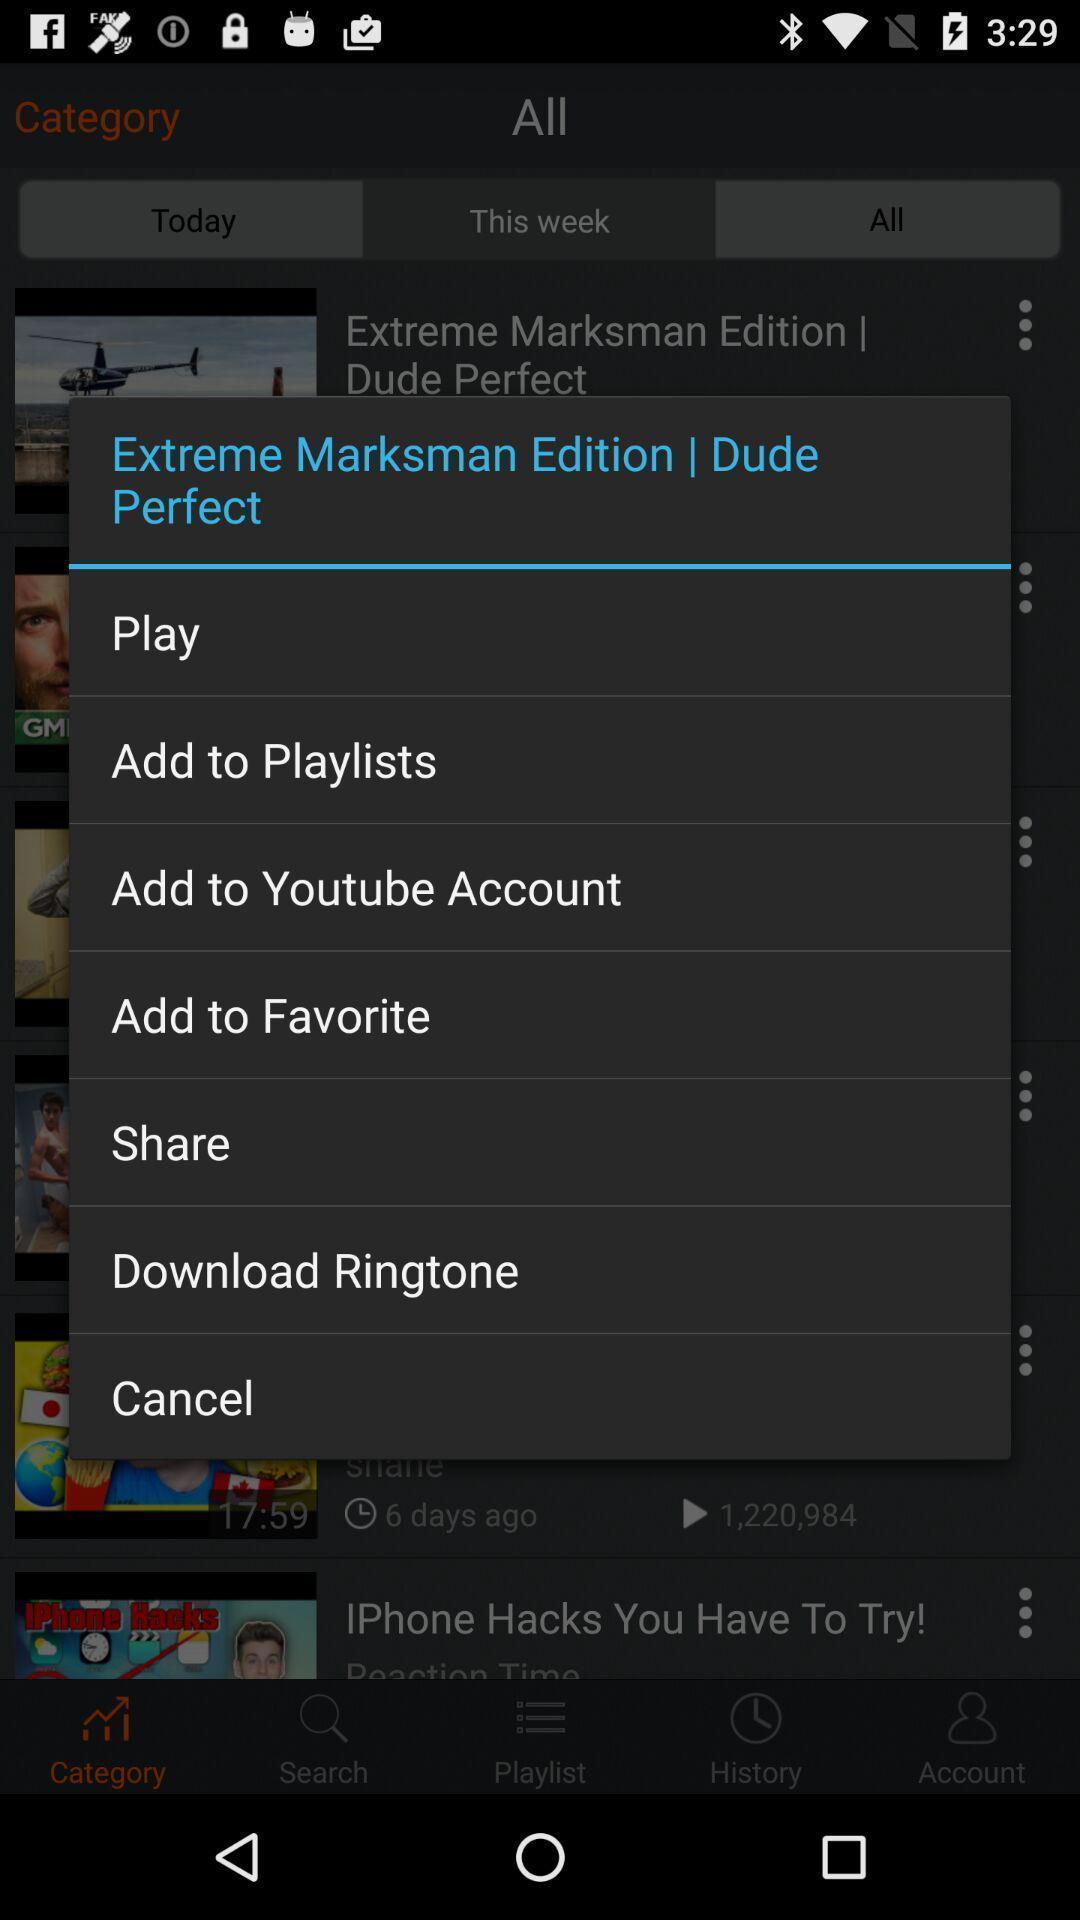Summarize the main components in this picture. Pop-up shows music playlists. 